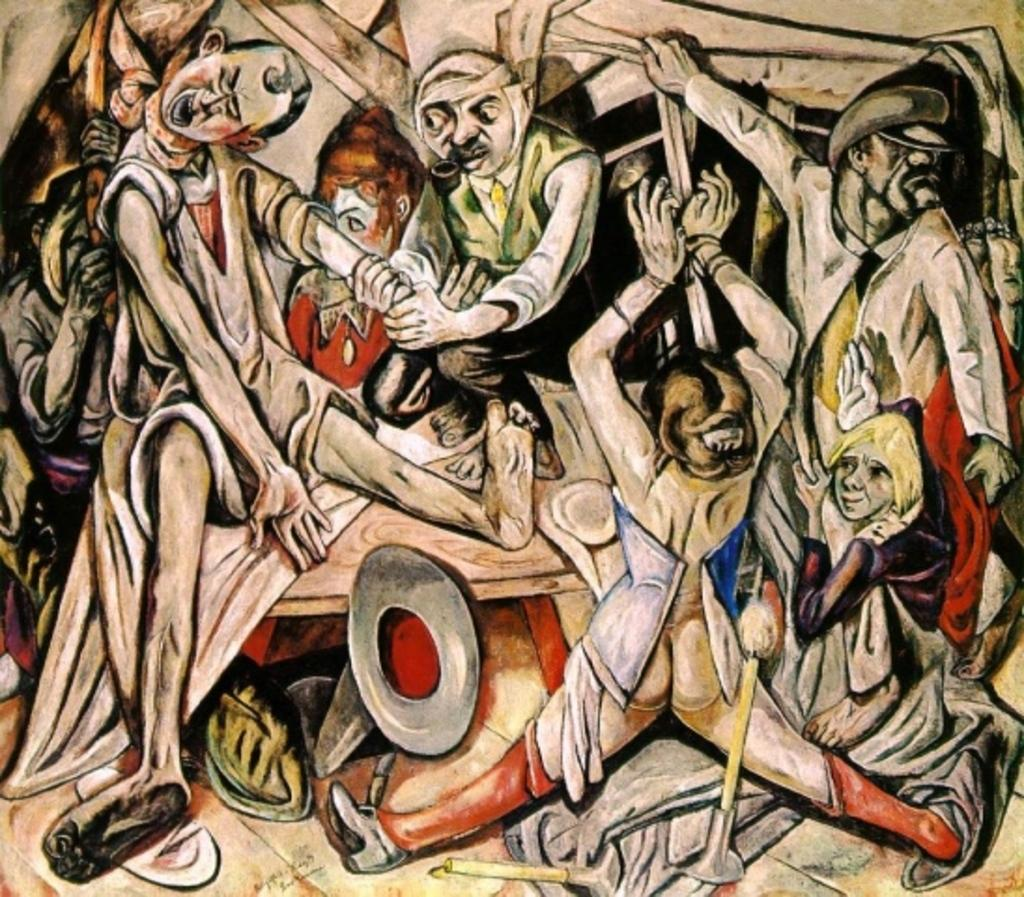What is depicted in the image? The image contains a drawing of people. Can you tell me how many people are running in the image? There is no indication of people running in the image, as it only contains a drawing of people. 